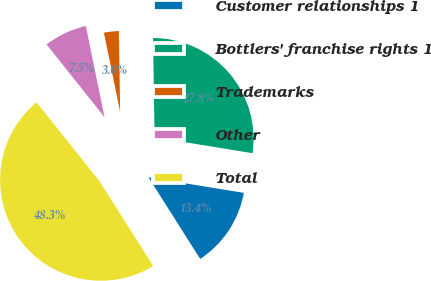Convert chart. <chart><loc_0><loc_0><loc_500><loc_500><pie_chart><fcel>Customer relationships 1<fcel>Bottlers' franchise rights 1<fcel>Trademarks<fcel>Other<fcel>Total<nl><fcel>13.44%<fcel>27.82%<fcel>2.97%<fcel>7.5%<fcel>48.27%<nl></chart> 